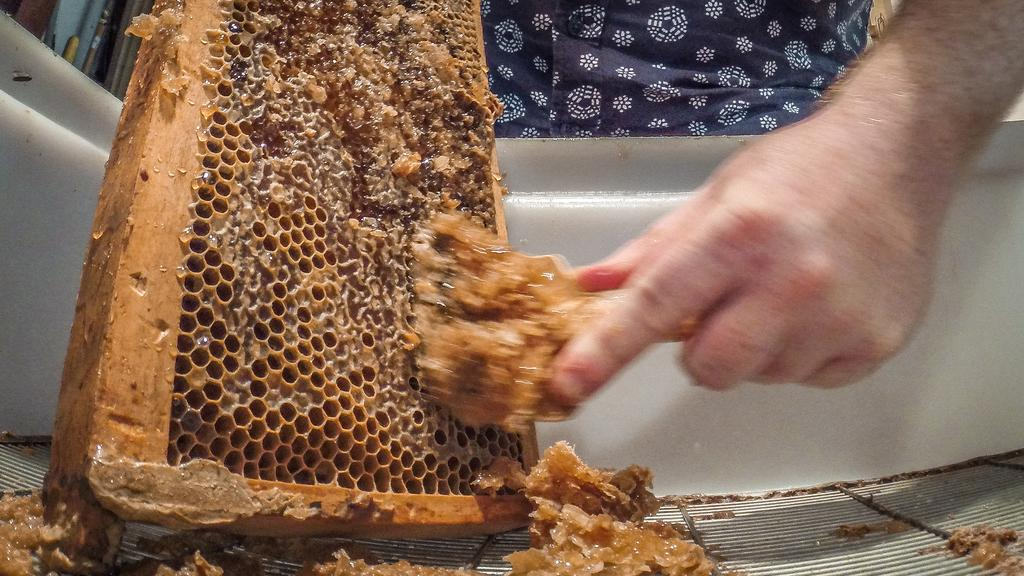What is the person in the image doing? The person is extracting wax in the image. What is the source of the wax being extracted? The wax is being extracted from a honeycomb. How is the honeycomb being contained or held? The honeycomb is in a container. What type of vegetable is being harvested in the image? There is no vegetable being harvested in the image; the person is extracting wax from a honeycomb. 